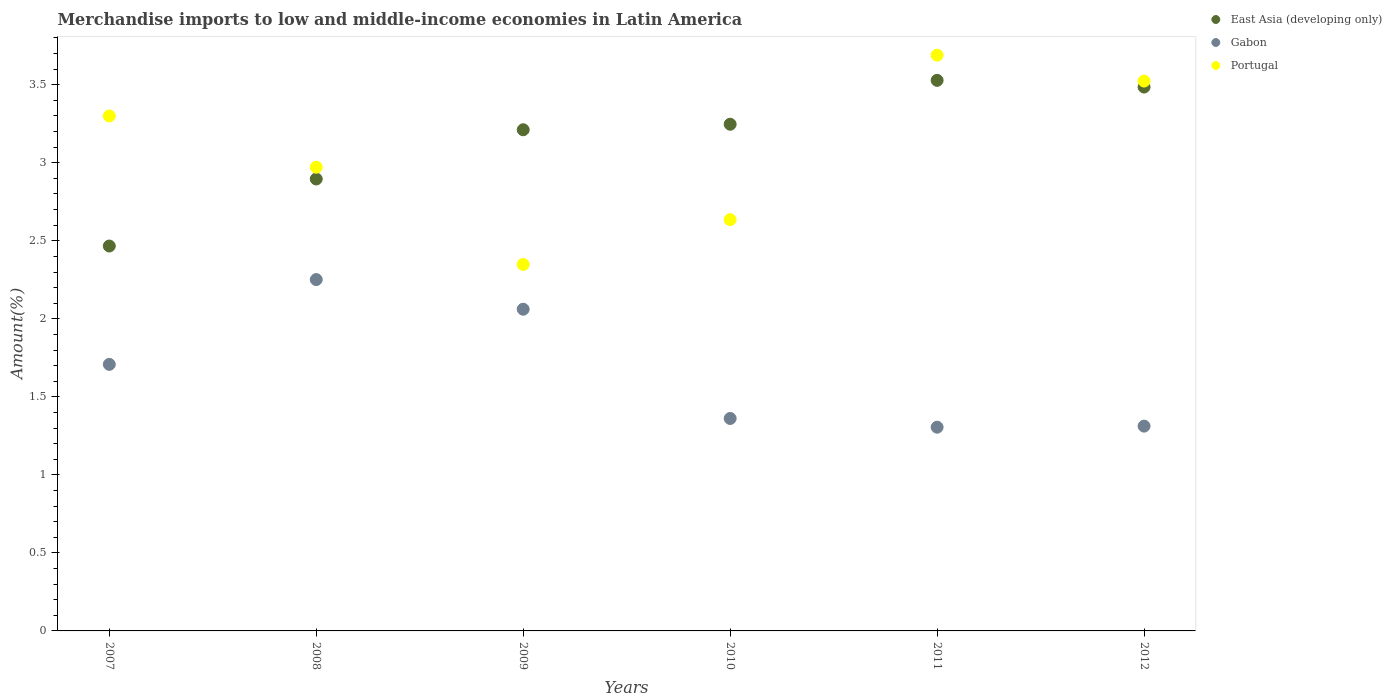How many different coloured dotlines are there?
Make the answer very short. 3. What is the percentage of amount earned from merchandise imports in Gabon in 2011?
Keep it short and to the point. 1.31. Across all years, what is the maximum percentage of amount earned from merchandise imports in Gabon?
Provide a succinct answer. 2.25. Across all years, what is the minimum percentage of amount earned from merchandise imports in East Asia (developing only)?
Provide a short and direct response. 2.47. In which year was the percentage of amount earned from merchandise imports in Gabon maximum?
Give a very brief answer. 2008. In which year was the percentage of amount earned from merchandise imports in East Asia (developing only) minimum?
Offer a very short reply. 2007. What is the total percentage of amount earned from merchandise imports in East Asia (developing only) in the graph?
Your answer should be very brief. 18.83. What is the difference between the percentage of amount earned from merchandise imports in Gabon in 2007 and that in 2008?
Offer a terse response. -0.54. What is the difference between the percentage of amount earned from merchandise imports in Gabon in 2011 and the percentage of amount earned from merchandise imports in Portugal in 2007?
Ensure brevity in your answer.  -1.99. What is the average percentage of amount earned from merchandise imports in Gabon per year?
Ensure brevity in your answer.  1.67. In the year 2009, what is the difference between the percentage of amount earned from merchandise imports in East Asia (developing only) and percentage of amount earned from merchandise imports in Gabon?
Ensure brevity in your answer.  1.15. In how many years, is the percentage of amount earned from merchandise imports in Gabon greater than 1.9 %?
Offer a terse response. 2. What is the ratio of the percentage of amount earned from merchandise imports in Portugal in 2009 to that in 2012?
Keep it short and to the point. 0.67. Is the percentage of amount earned from merchandise imports in East Asia (developing only) in 2007 less than that in 2009?
Give a very brief answer. Yes. Is the difference between the percentage of amount earned from merchandise imports in East Asia (developing only) in 2007 and 2008 greater than the difference between the percentage of amount earned from merchandise imports in Gabon in 2007 and 2008?
Keep it short and to the point. Yes. What is the difference between the highest and the second highest percentage of amount earned from merchandise imports in Portugal?
Keep it short and to the point. 0.17. What is the difference between the highest and the lowest percentage of amount earned from merchandise imports in Portugal?
Make the answer very short. 1.34. In how many years, is the percentage of amount earned from merchandise imports in East Asia (developing only) greater than the average percentage of amount earned from merchandise imports in East Asia (developing only) taken over all years?
Provide a short and direct response. 4. Is the sum of the percentage of amount earned from merchandise imports in East Asia (developing only) in 2007 and 2009 greater than the maximum percentage of amount earned from merchandise imports in Gabon across all years?
Provide a short and direct response. Yes. Does the percentage of amount earned from merchandise imports in Portugal monotonically increase over the years?
Give a very brief answer. No. Is the percentage of amount earned from merchandise imports in East Asia (developing only) strictly less than the percentage of amount earned from merchandise imports in Portugal over the years?
Offer a terse response. No. What is the difference between two consecutive major ticks on the Y-axis?
Ensure brevity in your answer.  0.5. Are the values on the major ticks of Y-axis written in scientific E-notation?
Give a very brief answer. No. Does the graph contain grids?
Your response must be concise. No. How are the legend labels stacked?
Your answer should be compact. Vertical. What is the title of the graph?
Offer a terse response. Merchandise imports to low and middle-income economies in Latin America. What is the label or title of the Y-axis?
Your response must be concise. Amount(%). What is the Amount(%) in East Asia (developing only) in 2007?
Provide a short and direct response. 2.47. What is the Amount(%) in Gabon in 2007?
Offer a terse response. 1.71. What is the Amount(%) in Portugal in 2007?
Offer a terse response. 3.3. What is the Amount(%) in East Asia (developing only) in 2008?
Your response must be concise. 2.9. What is the Amount(%) of Gabon in 2008?
Your response must be concise. 2.25. What is the Amount(%) in Portugal in 2008?
Provide a succinct answer. 2.97. What is the Amount(%) in East Asia (developing only) in 2009?
Make the answer very short. 3.21. What is the Amount(%) of Gabon in 2009?
Provide a succinct answer. 2.06. What is the Amount(%) of Portugal in 2009?
Offer a very short reply. 2.35. What is the Amount(%) of East Asia (developing only) in 2010?
Your response must be concise. 3.25. What is the Amount(%) in Gabon in 2010?
Keep it short and to the point. 1.36. What is the Amount(%) in Portugal in 2010?
Keep it short and to the point. 2.64. What is the Amount(%) of East Asia (developing only) in 2011?
Make the answer very short. 3.53. What is the Amount(%) of Gabon in 2011?
Your response must be concise. 1.31. What is the Amount(%) in Portugal in 2011?
Give a very brief answer. 3.69. What is the Amount(%) in East Asia (developing only) in 2012?
Offer a terse response. 3.49. What is the Amount(%) in Gabon in 2012?
Offer a very short reply. 1.31. What is the Amount(%) in Portugal in 2012?
Provide a succinct answer. 3.52. Across all years, what is the maximum Amount(%) of East Asia (developing only)?
Your response must be concise. 3.53. Across all years, what is the maximum Amount(%) in Gabon?
Provide a short and direct response. 2.25. Across all years, what is the maximum Amount(%) of Portugal?
Ensure brevity in your answer.  3.69. Across all years, what is the minimum Amount(%) of East Asia (developing only)?
Give a very brief answer. 2.47. Across all years, what is the minimum Amount(%) in Gabon?
Your answer should be very brief. 1.31. Across all years, what is the minimum Amount(%) of Portugal?
Your answer should be compact. 2.35. What is the total Amount(%) in East Asia (developing only) in the graph?
Your answer should be compact. 18.83. What is the total Amount(%) in Gabon in the graph?
Your answer should be very brief. 10. What is the total Amount(%) in Portugal in the graph?
Your answer should be very brief. 18.47. What is the difference between the Amount(%) in East Asia (developing only) in 2007 and that in 2008?
Offer a very short reply. -0.43. What is the difference between the Amount(%) in Gabon in 2007 and that in 2008?
Keep it short and to the point. -0.54. What is the difference between the Amount(%) in Portugal in 2007 and that in 2008?
Make the answer very short. 0.33. What is the difference between the Amount(%) in East Asia (developing only) in 2007 and that in 2009?
Provide a short and direct response. -0.74. What is the difference between the Amount(%) of Gabon in 2007 and that in 2009?
Your answer should be very brief. -0.35. What is the difference between the Amount(%) in Portugal in 2007 and that in 2009?
Keep it short and to the point. 0.95. What is the difference between the Amount(%) in East Asia (developing only) in 2007 and that in 2010?
Provide a short and direct response. -0.78. What is the difference between the Amount(%) of Gabon in 2007 and that in 2010?
Offer a terse response. 0.35. What is the difference between the Amount(%) of Portugal in 2007 and that in 2010?
Keep it short and to the point. 0.66. What is the difference between the Amount(%) of East Asia (developing only) in 2007 and that in 2011?
Give a very brief answer. -1.06. What is the difference between the Amount(%) of Gabon in 2007 and that in 2011?
Your answer should be compact. 0.4. What is the difference between the Amount(%) of Portugal in 2007 and that in 2011?
Ensure brevity in your answer.  -0.39. What is the difference between the Amount(%) of East Asia (developing only) in 2007 and that in 2012?
Keep it short and to the point. -1.02. What is the difference between the Amount(%) in Gabon in 2007 and that in 2012?
Offer a very short reply. 0.4. What is the difference between the Amount(%) of Portugal in 2007 and that in 2012?
Your answer should be very brief. -0.22. What is the difference between the Amount(%) of East Asia (developing only) in 2008 and that in 2009?
Offer a terse response. -0.32. What is the difference between the Amount(%) in Gabon in 2008 and that in 2009?
Your answer should be very brief. 0.19. What is the difference between the Amount(%) in Portugal in 2008 and that in 2009?
Give a very brief answer. 0.62. What is the difference between the Amount(%) of East Asia (developing only) in 2008 and that in 2010?
Ensure brevity in your answer.  -0.35. What is the difference between the Amount(%) in Gabon in 2008 and that in 2010?
Your answer should be very brief. 0.89. What is the difference between the Amount(%) of Portugal in 2008 and that in 2010?
Ensure brevity in your answer.  0.34. What is the difference between the Amount(%) in East Asia (developing only) in 2008 and that in 2011?
Your response must be concise. -0.63. What is the difference between the Amount(%) in Gabon in 2008 and that in 2011?
Keep it short and to the point. 0.95. What is the difference between the Amount(%) of Portugal in 2008 and that in 2011?
Make the answer very short. -0.72. What is the difference between the Amount(%) in East Asia (developing only) in 2008 and that in 2012?
Keep it short and to the point. -0.59. What is the difference between the Amount(%) in Gabon in 2008 and that in 2012?
Your response must be concise. 0.94. What is the difference between the Amount(%) in Portugal in 2008 and that in 2012?
Ensure brevity in your answer.  -0.55. What is the difference between the Amount(%) in East Asia (developing only) in 2009 and that in 2010?
Your answer should be compact. -0.04. What is the difference between the Amount(%) in Gabon in 2009 and that in 2010?
Offer a very short reply. 0.7. What is the difference between the Amount(%) of Portugal in 2009 and that in 2010?
Your response must be concise. -0.29. What is the difference between the Amount(%) of East Asia (developing only) in 2009 and that in 2011?
Offer a very short reply. -0.32. What is the difference between the Amount(%) of Gabon in 2009 and that in 2011?
Give a very brief answer. 0.76. What is the difference between the Amount(%) in Portugal in 2009 and that in 2011?
Your answer should be compact. -1.34. What is the difference between the Amount(%) in East Asia (developing only) in 2009 and that in 2012?
Offer a terse response. -0.27. What is the difference between the Amount(%) in Gabon in 2009 and that in 2012?
Provide a succinct answer. 0.75. What is the difference between the Amount(%) in Portugal in 2009 and that in 2012?
Offer a terse response. -1.18. What is the difference between the Amount(%) of East Asia (developing only) in 2010 and that in 2011?
Offer a terse response. -0.28. What is the difference between the Amount(%) of Gabon in 2010 and that in 2011?
Offer a terse response. 0.06. What is the difference between the Amount(%) in Portugal in 2010 and that in 2011?
Offer a very short reply. -1.05. What is the difference between the Amount(%) in East Asia (developing only) in 2010 and that in 2012?
Offer a terse response. -0.24. What is the difference between the Amount(%) in Gabon in 2010 and that in 2012?
Offer a very short reply. 0.05. What is the difference between the Amount(%) of Portugal in 2010 and that in 2012?
Give a very brief answer. -0.89. What is the difference between the Amount(%) in East Asia (developing only) in 2011 and that in 2012?
Your response must be concise. 0.04. What is the difference between the Amount(%) in Gabon in 2011 and that in 2012?
Offer a terse response. -0.01. What is the difference between the Amount(%) in Portugal in 2011 and that in 2012?
Provide a short and direct response. 0.17. What is the difference between the Amount(%) in East Asia (developing only) in 2007 and the Amount(%) in Gabon in 2008?
Your answer should be very brief. 0.22. What is the difference between the Amount(%) of East Asia (developing only) in 2007 and the Amount(%) of Portugal in 2008?
Make the answer very short. -0.5. What is the difference between the Amount(%) in Gabon in 2007 and the Amount(%) in Portugal in 2008?
Offer a very short reply. -1.26. What is the difference between the Amount(%) of East Asia (developing only) in 2007 and the Amount(%) of Gabon in 2009?
Provide a succinct answer. 0.41. What is the difference between the Amount(%) in East Asia (developing only) in 2007 and the Amount(%) in Portugal in 2009?
Keep it short and to the point. 0.12. What is the difference between the Amount(%) of Gabon in 2007 and the Amount(%) of Portugal in 2009?
Provide a short and direct response. -0.64. What is the difference between the Amount(%) of East Asia (developing only) in 2007 and the Amount(%) of Gabon in 2010?
Provide a short and direct response. 1.11. What is the difference between the Amount(%) of East Asia (developing only) in 2007 and the Amount(%) of Portugal in 2010?
Your answer should be very brief. -0.17. What is the difference between the Amount(%) in Gabon in 2007 and the Amount(%) in Portugal in 2010?
Make the answer very short. -0.93. What is the difference between the Amount(%) in East Asia (developing only) in 2007 and the Amount(%) in Gabon in 2011?
Make the answer very short. 1.16. What is the difference between the Amount(%) in East Asia (developing only) in 2007 and the Amount(%) in Portugal in 2011?
Your answer should be compact. -1.22. What is the difference between the Amount(%) in Gabon in 2007 and the Amount(%) in Portugal in 2011?
Offer a very short reply. -1.98. What is the difference between the Amount(%) in East Asia (developing only) in 2007 and the Amount(%) in Gabon in 2012?
Offer a very short reply. 1.15. What is the difference between the Amount(%) of East Asia (developing only) in 2007 and the Amount(%) of Portugal in 2012?
Provide a short and direct response. -1.06. What is the difference between the Amount(%) in Gabon in 2007 and the Amount(%) in Portugal in 2012?
Provide a short and direct response. -1.82. What is the difference between the Amount(%) of East Asia (developing only) in 2008 and the Amount(%) of Gabon in 2009?
Make the answer very short. 0.83. What is the difference between the Amount(%) in East Asia (developing only) in 2008 and the Amount(%) in Portugal in 2009?
Provide a succinct answer. 0.55. What is the difference between the Amount(%) in Gabon in 2008 and the Amount(%) in Portugal in 2009?
Provide a short and direct response. -0.1. What is the difference between the Amount(%) in East Asia (developing only) in 2008 and the Amount(%) in Gabon in 2010?
Your answer should be very brief. 1.53. What is the difference between the Amount(%) in East Asia (developing only) in 2008 and the Amount(%) in Portugal in 2010?
Ensure brevity in your answer.  0.26. What is the difference between the Amount(%) in Gabon in 2008 and the Amount(%) in Portugal in 2010?
Ensure brevity in your answer.  -0.38. What is the difference between the Amount(%) of East Asia (developing only) in 2008 and the Amount(%) of Gabon in 2011?
Make the answer very short. 1.59. What is the difference between the Amount(%) in East Asia (developing only) in 2008 and the Amount(%) in Portugal in 2011?
Make the answer very short. -0.79. What is the difference between the Amount(%) in Gabon in 2008 and the Amount(%) in Portugal in 2011?
Provide a succinct answer. -1.44. What is the difference between the Amount(%) of East Asia (developing only) in 2008 and the Amount(%) of Gabon in 2012?
Offer a very short reply. 1.58. What is the difference between the Amount(%) of East Asia (developing only) in 2008 and the Amount(%) of Portugal in 2012?
Provide a short and direct response. -0.63. What is the difference between the Amount(%) of Gabon in 2008 and the Amount(%) of Portugal in 2012?
Make the answer very short. -1.27. What is the difference between the Amount(%) in East Asia (developing only) in 2009 and the Amount(%) in Gabon in 2010?
Ensure brevity in your answer.  1.85. What is the difference between the Amount(%) of East Asia (developing only) in 2009 and the Amount(%) of Portugal in 2010?
Your response must be concise. 0.58. What is the difference between the Amount(%) of Gabon in 2009 and the Amount(%) of Portugal in 2010?
Your answer should be compact. -0.57. What is the difference between the Amount(%) of East Asia (developing only) in 2009 and the Amount(%) of Gabon in 2011?
Your answer should be very brief. 1.91. What is the difference between the Amount(%) in East Asia (developing only) in 2009 and the Amount(%) in Portugal in 2011?
Your answer should be compact. -0.48. What is the difference between the Amount(%) of Gabon in 2009 and the Amount(%) of Portugal in 2011?
Offer a terse response. -1.63. What is the difference between the Amount(%) in East Asia (developing only) in 2009 and the Amount(%) in Gabon in 2012?
Provide a short and direct response. 1.9. What is the difference between the Amount(%) in East Asia (developing only) in 2009 and the Amount(%) in Portugal in 2012?
Offer a very short reply. -0.31. What is the difference between the Amount(%) in Gabon in 2009 and the Amount(%) in Portugal in 2012?
Ensure brevity in your answer.  -1.46. What is the difference between the Amount(%) of East Asia (developing only) in 2010 and the Amount(%) of Gabon in 2011?
Your answer should be compact. 1.94. What is the difference between the Amount(%) in East Asia (developing only) in 2010 and the Amount(%) in Portugal in 2011?
Make the answer very short. -0.44. What is the difference between the Amount(%) of Gabon in 2010 and the Amount(%) of Portugal in 2011?
Your response must be concise. -2.33. What is the difference between the Amount(%) of East Asia (developing only) in 2010 and the Amount(%) of Gabon in 2012?
Keep it short and to the point. 1.93. What is the difference between the Amount(%) of East Asia (developing only) in 2010 and the Amount(%) of Portugal in 2012?
Keep it short and to the point. -0.28. What is the difference between the Amount(%) of Gabon in 2010 and the Amount(%) of Portugal in 2012?
Your answer should be compact. -2.16. What is the difference between the Amount(%) in East Asia (developing only) in 2011 and the Amount(%) in Gabon in 2012?
Give a very brief answer. 2.22. What is the difference between the Amount(%) of East Asia (developing only) in 2011 and the Amount(%) of Portugal in 2012?
Provide a succinct answer. 0. What is the difference between the Amount(%) of Gabon in 2011 and the Amount(%) of Portugal in 2012?
Provide a short and direct response. -2.22. What is the average Amount(%) of East Asia (developing only) per year?
Your response must be concise. 3.14. What is the average Amount(%) of Gabon per year?
Provide a short and direct response. 1.67. What is the average Amount(%) in Portugal per year?
Offer a very short reply. 3.08. In the year 2007, what is the difference between the Amount(%) in East Asia (developing only) and Amount(%) in Gabon?
Ensure brevity in your answer.  0.76. In the year 2007, what is the difference between the Amount(%) in East Asia (developing only) and Amount(%) in Portugal?
Keep it short and to the point. -0.83. In the year 2007, what is the difference between the Amount(%) in Gabon and Amount(%) in Portugal?
Offer a terse response. -1.59. In the year 2008, what is the difference between the Amount(%) in East Asia (developing only) and Amount(%) in Gabon?
Offer a terse response. 0.64. In the year 2008, what is the difference between the Amount(%) in East Asia (developing only) and Amount(%) in Portugal?
Your response must be concise. -0.08. In the year 2008, what is the difference between the Amount(%) of Gabon and Amount(%) of Portugal?
Your answer should be compact. -0.72. In the year 2009, what is the difference between the Amount(%) of East Asia (developing only) and Amount(%) of Gabon?
Ensure brevity in your answer.  1.15. In the year 2009, what is the difference between the Amount(%) of East Asia (developing only) and Amount(%) of Portugal?
Ensure brevity in your answer.  0.86. In the year 2009, what is the difference between the Amount(%) of Gabon and Amount(%) of Portugal?
Provide a short and direct response. -0.29. In the year 2010, what is the difference between the Amount(%) of East Asia (developing only) and Amount(%) of Gabon?
Offer a very short reply. 1.89. In the year 2010, what is the difference between the Amount(%) in East Asia (developing only) and Amount(%) in Portugal?
Ensure brevity in your answer.  0.61. In the year 2010, what is the difference between the Amount(%) in Gabon and Amount(%) in Portugal?
Your response must be concise. -1.27. In the year 2011, what is the difference between the Amount(%) of East Asia (developing only) and Amount(%) of Gabon?
Your response must be concise. 2.22. In the year 2011, what is the difference between the Amount(%) of East Asia (developing only) and Amount(%) of Portugal?
Make the answer very short. -0.16. In the year 2011, what is the difference between the Amount(%) in Gabon and Amount(%) in Portugal?
Make the answer very short. -2.38. In the year 2012, what is the difference between the Amount(%) in East Asia (developing only) and Amount(%) in Gabon?
Provide a succinct answer. 2.17. In the year 2012, what is the difference between the Amount(%) in East Asia (developing only) and Amount(%) in Portugal?
Provide a short and direct response. -0.04. In the year 2012, what is the difference between the Amount(%) of Gabon and Amount(%) of Portugal?
Offer a very short reply. -2.21. What is the ratio of the Amount(%) in East Asia (developing only) in 2007 to that in 2008?
Provide a short and direct response. 0.85. What is the ratio of the Amount(%) of Gabon in 2007 to that in 2008?
Keep it short and to the point. 0.76. What is the ratio of the Amount(%) in Portugal in 2007 to that in 2008?
Keep it short and to the point. 1.11. What is the ratio of the Amount(%) in East Asia (developing only) in 2007 to that in 2009?
Offer a terse response. 0.77. What is the ratio of the Amount(%) of Gabon in 2007 to that in 2009?
Offer a very short reply. 0.83. What is the ratio of the Amount(%) of Portugal in 2007 to that in 2009?
Your response must be concise. 1.41. What is the ratio of the Amount(%) in East Asia (developing only) in 2007 to that in 2010?
Provide a short and direct response. 0.76. What is the ratio of the Amount(%) of Gabon in 2007 to that in 2010?
Give a very brief answer. 1.25. What is the ratio of the Amount(%) of Portugal in 2007 to that in 2010?
Make the answer very short. 1.25. What is the ratio of the Amount(%) of East Asia (developing only) in 2007 to that in 2011?
Keep it short and to the point. 0.7. What is the ratio of the Amount(%) in Gabon in 2007 to that in 2011?
Give a very brief answer. 1.31. What is the ratio of the Amount(%) of Portugal in 2007 to that in 2011?
Your answer should be compact. 0.89. What is the ratio of the Amount(%) in East Asia (developing only) in 2007 to that in 2012?
Give a very brief answer. 0.71. What is the ratio of the Amount(%) in Gabon in 2007 to that in 2012?
Provide a succinct answer. 1.3. What is the ratio of the Amount(%) in Portugal in 2007 to that in 2012?
Give a very brief answer. 0.94. What is the ratio of the Amount(%) of East Asia (developing only) in 2008 to that in 2009?
Make the answer very short. 0.9. What is the ratio of the Amount(%) in Gabon in 2008 to that in 2009?
Ensure brevity in your answer.  1.09. What is the ratio of the Amount(%) of Portugal in 2008 to that in 2009?
Make the answer very short. 1.27. What is the ratio of the Amount(%) of East Asia (developing only) in 2008 to that in 2010?
Ensure brevity in your answer.  0.89. What is the ratio of the Amount(%) in Gabon in 2008 to that in 2010?
Your answer should be compact. 1.65. What is the ratio of the Amount(%) in Portugal in 2008 to that in 2010?
Keep it short and to the point. 1.13. What is the ratio of the Amount(%) in East Asia (developing only) in 2008 to that in 2011?
Keep it short and to the point. 0.82. What is the ratio of the Amount(%) of Gabon in 2008 to that in 2011?
Offer a terse response. 1.72. What is the ratio of the Amount(%) in Portugal in 2008 to that in 2011?
Offer a terse response. 0.81. What is the ratio of the Amount(%) of East Asia (developing only) in 2008 to that in 2012?
Provide a succinct answer. 0.83. What is the ratio of the Amount(%) in Gabon in 2008 to that in 2012?
Provide a succinct answer. 1.72. What is the ratio of the Amount(%) in Portugal in 2008 to that in 2012?
Ensure brevity in your answer.  0.84. What is the ratio of the Amount(%) of East Asia (developing only) in 2009 to that in 2010?
Keep it short and to the point. 0.99. What is the ratio of the Amount(%) of Gabon in 2009 to that in 2010?
Provide a succinct answer. 1.51. What is the ratio of the Amount(%) in Portugal in 2009 to that in 2010?
Your answer should be very brief. 0.89. What is the ratio of the Amount(%) in East Asia (developing only) in 2009 to that in 2011?
Make the answer very short. 0.91. What is the ratio of the Amount(%) in Gabon in 2009 to that in 2011?
Your response must be concise. 1.58. What is the ratio of the Amount(%) in Portugal in 2009 to that in 2011?
Offer a very short reply. 0.64. What is the ratio of the Amount(%) of East Asia (developing only) in 2009 to that in 2012?
Give a very brief answer. 0.92. What is the ratio of the Amount(%) in Gabon in 2009 to that in 2012?
Make the answer very short. 1.57. What is the ratio of the Amount(%) of Portugal in 2009 to that in 2012?
Give a very brief answer. 0.67. What is the ratio of the Amount(%) of East Asia (developing only) in 2010 to that in 2011?
Make the answer very short. 0.92. What is the ratio of the Amount(%) of Gabon in 2010 to that in 2011?
Offer a terse response. 1.04. What is the ratio of the Amount(%) in Portugal in 2010 to that in 2011?
Offer a terse response. 0.71. What is the ratio of the Amount(%) in East Asia (developing only) in 2010 to that in 2012?
Offer a very short reply. 0.93. What is the ratio of the Amount(%) of Gabon in 2010 to that in 2012?
Your response must be concise. 1.04. What is the ratio of the Amount(%) of Portugal in 2010 to that in 2012?
Offer a very short reply. 0.75. What is the ratio of the Amount(%) in East Asia (developing only) in 2011 to that in 2012?
Your response must be concise. 1.01. What is the ratio of the Amount(%) of Portugal in 2011 to that in 2012?
Keep it short and to the point. 1.05. What is the difference between the highest and the second highest Amount(%) of East Asia (developing only)?
Keep it short and to the point. 0.04. What is the difference between the highest and the second highest Amount(%) in Gabon?
Offer a terse response. 0.19. What is the difference between the highest and the second highest Amount(%) in Portugal?
Your answer should be compact. 0.17. What is the difference between the highest and the lowest Amount(%) of East Asia (developing only)?
Provide a short and direct response. 1.06. What is the difference between the highest and the lowest Amount(%) of Gabon?
Offer a terse response. 0.95. What is the difference between the highest and the lowest Amount(%) of Portugal?
Provide a short and direct response. 1.34. 